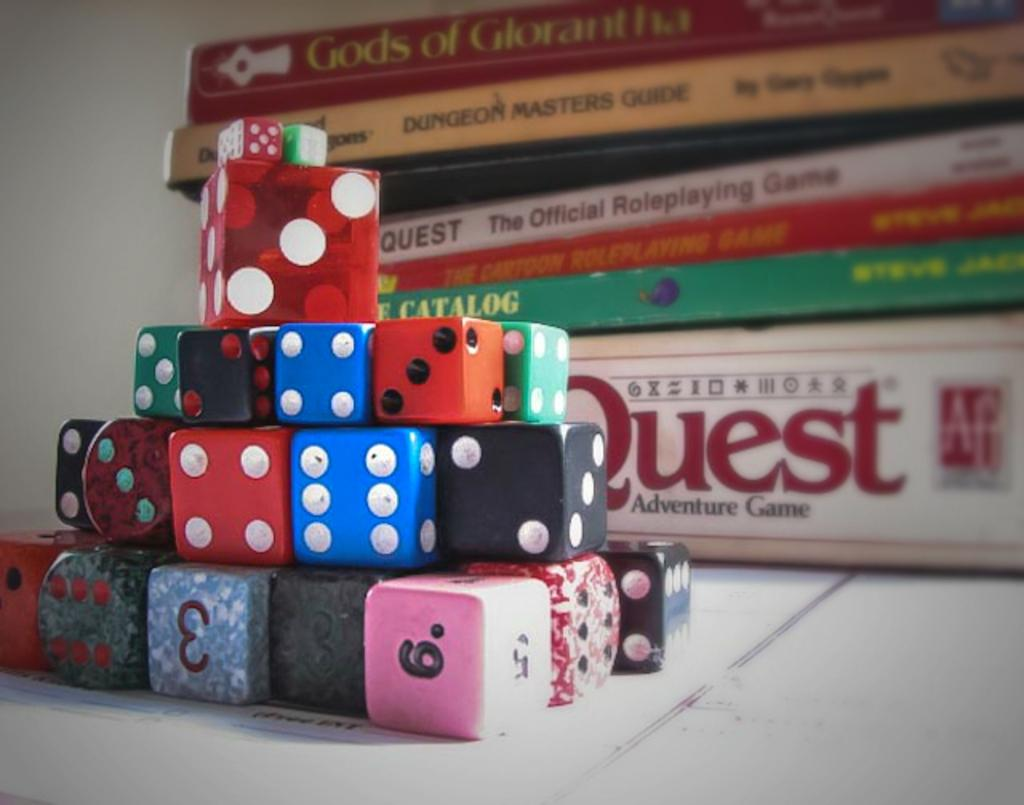<image>
Create a compact narrative representing the image presented. Stack of books with a Quest Adventure game at the bottom and dice of various colors in front. 